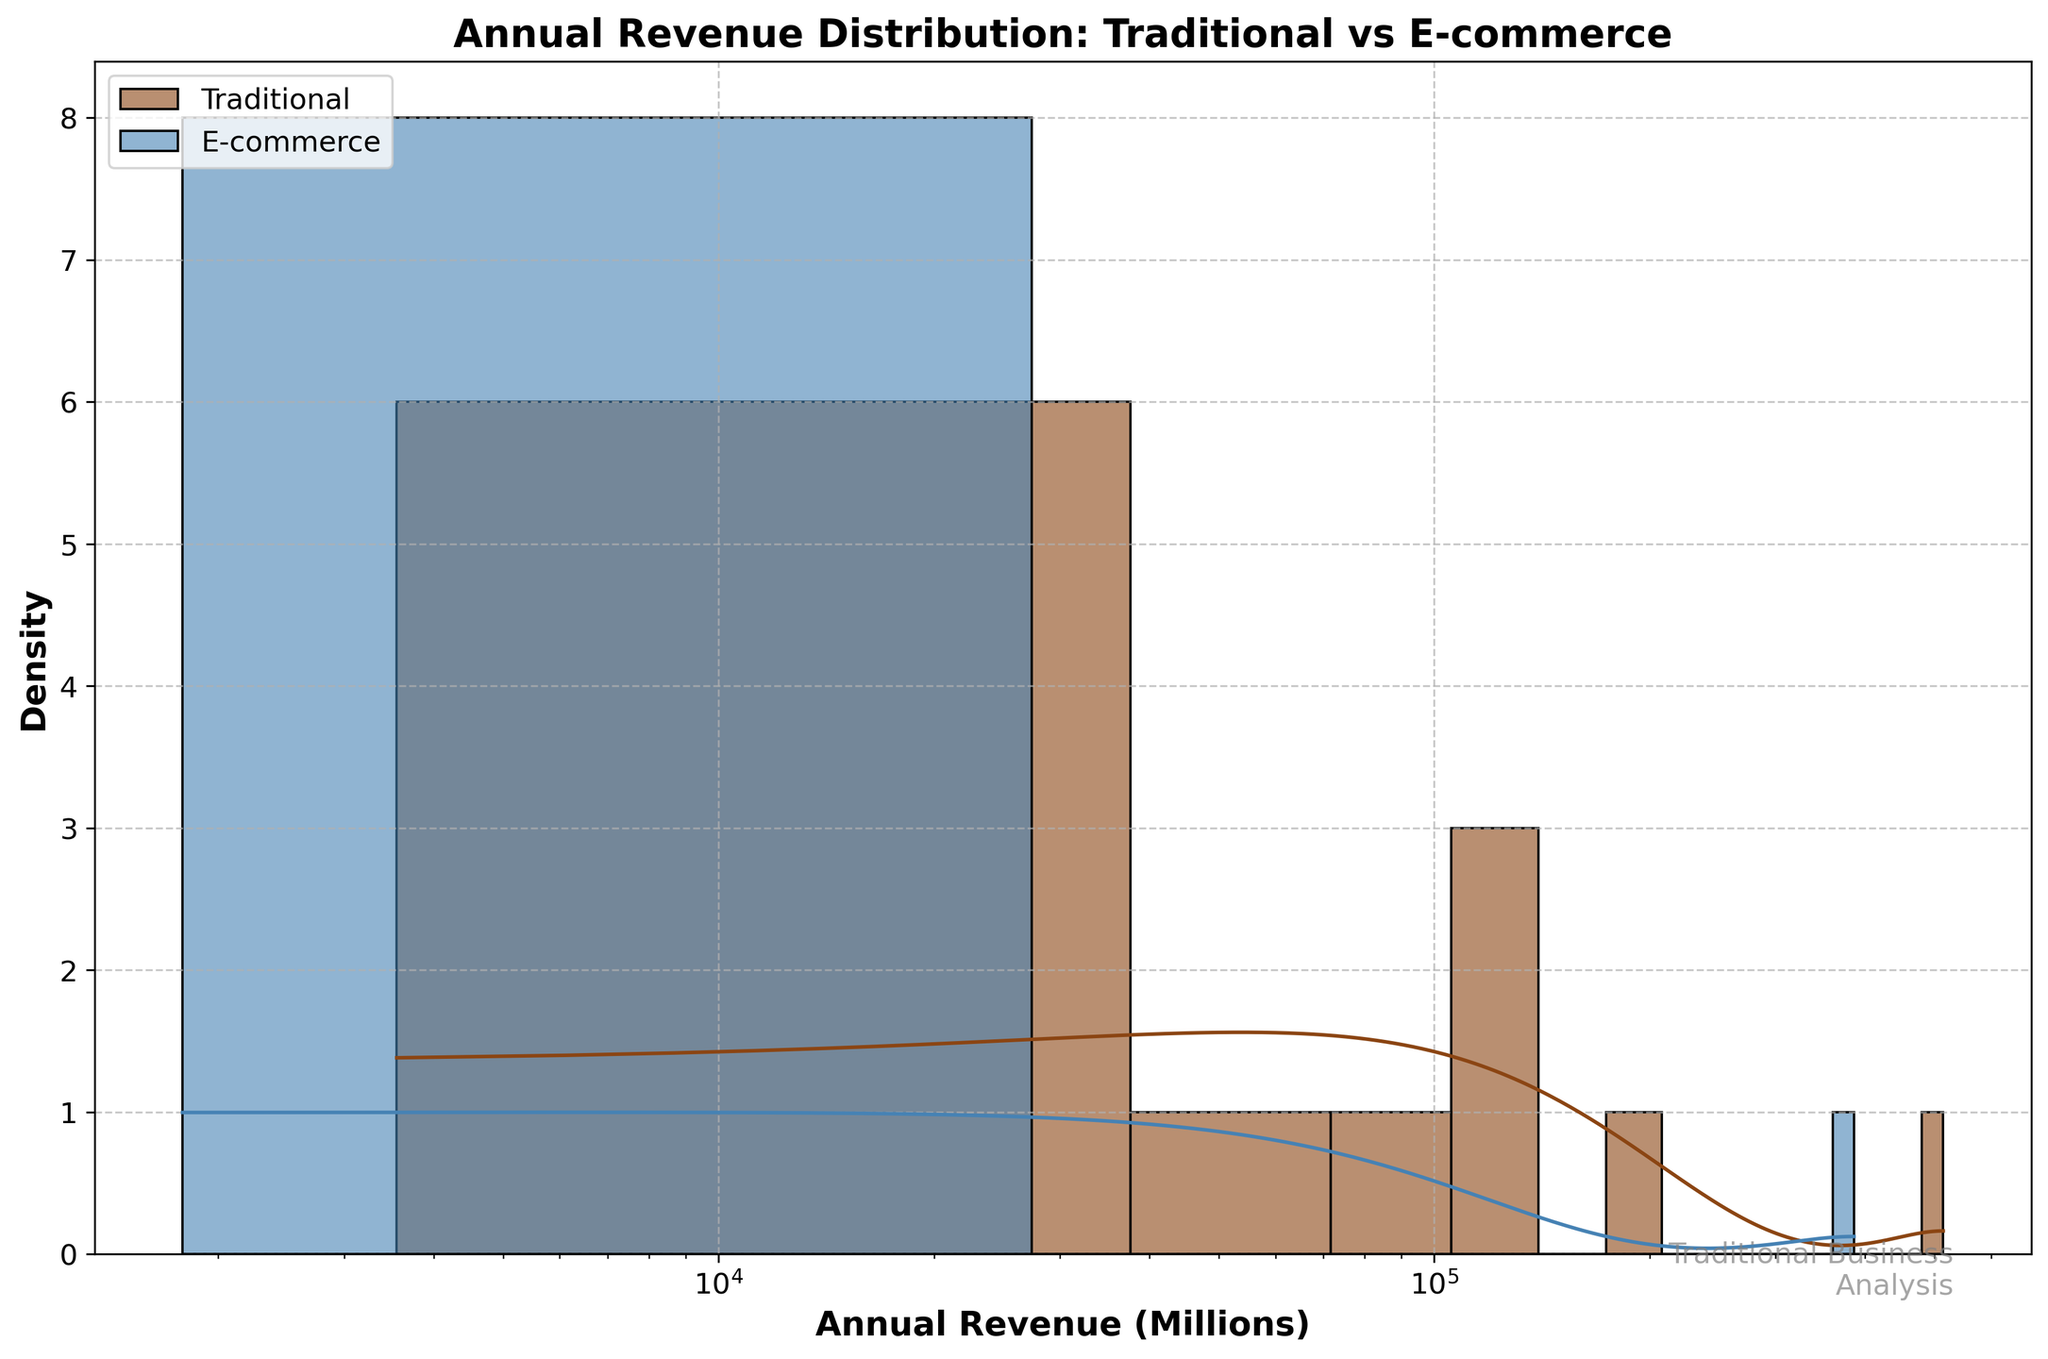What is the title of the plot? The title of the plot is located at the top of the figure. It reads "Annual Revenue Distribution: Traditional vs E-commerce".
Answer: "Annual Revenue Distribution: Traditional vs E-commerce" What scale is used on the x-axis? By observing the x-axis, we can see that the labels are spaced logarithmically, indicating that a logarithmic scale is used.
Answer: Logarithmic scale How many colors are used to represent different company types? The figure uses two different colors to represent different company types: one for traditional companies and one for e-commerce companies.
Answer: Two Which company type appears to have a higher density curve peak in the annual revenue distribution? By looking at the KDE (density curve), the peak for traditional companies is higher than the peak for e-commerce companies. This indicates traditional companies have a higher density in the midrange of annual revenues.
Answer: Traditional companies Do traditional companies have higher revenue than e-commerce companies? By examining the position of the peaks and the spread on the logarithmic x-axis, traditional companies generally have higher revenue distributions compared to e-commerce companies.
Answer: Yes, higher revenue What is the range of annual revenue (in millions) for e-commerce companies shown in the figure? From observing the x-axis positions marked for e-commerce companies, they range approximately from 1 million to over 100,000 million in annual revenue.
Answer: Approximately 1 million to 100,000 million How does the spread of annual revenues for traditional companies compare to e-commerce companies? Traditional companies appear to have a wider spread on the logarithmic scale compared to e-commerce companies, which primarily cluster at lower ranges.
Answer: Wider spread for traditional Is there any overlap in the annual revenue range between traditional and e-commerce companies? The figure shows that both traditional and e-commerce companies have overlapping ranges in the lower and mid revenues, but traditional companies extend significantly higher.
Answer: Yes, there is overlap Which company type is more consistent in terms of annual revenue distribution based on the density curves? The KDE (density curve) for e-commerce companies is more concentrated and narrower, indicating they have a more consistent annual revenue distribution compared to traditional companies.
Answer: E-commerce companies Would you say the traditional companies or e-commerce companies have a greater number of extremely high revenue entities? Traditional companies appear to have more entities with extremely high revenues based on the KDE extending higher on the logarithmic scale compared to e-commerce companies.
Answer: Traditional companies 